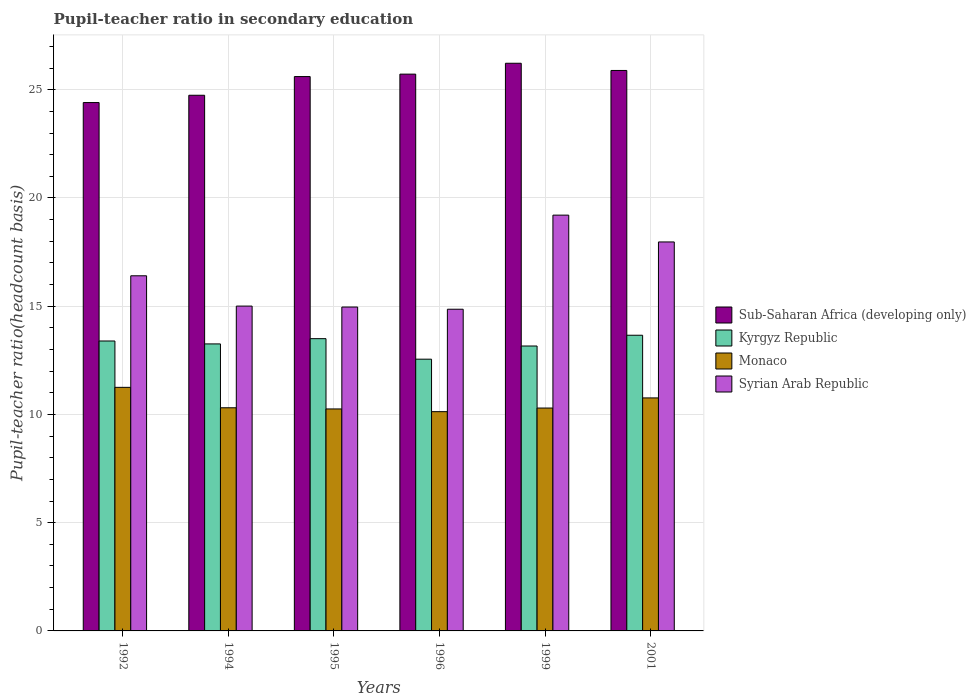How many groups of bars are there?
Keep it short and to the point. 6. How many bars are there on the 1st tick from the left?
Your response must be concise. 4. What is the label of the 6th group of bars from the left?
Ensure brevity in your answer.  2001. What is the pupil-teacher ratio in secondary education in Sub-Saharan Africa (developing only) in 1999?
Your answer should be very brief. 26.22. Across all years, what is the maximum pupil-teacher ratio in secondary education in Monaco?
Your answer should be very brief. 11.25. Across all years, what is the minimum pupil-teacher ratio in secondary education in Monaco?
Provide a short and direct response. 10.13. In which year was the pupil-teacher ratio in secondary education in Kyrgyz Republic maximum?
Ensure brevity in your answer.  2001. In which year was the pupil-teacher ratio in secondary education in Kyrgyz Republic minimum?
Keep it short and to the point. 1996. What is the total pupil-teacher ratio in secondary education in Sub-Saharan Africa (developing only) in the graph?
Make the answer very short. 152.6. What is the difference between the pupil-teacher ratio in secondary education in Sub-Saharan Africa (developing only) in 1992 and that in 1995?
Ensure brevity in your answer.  -1.2. What is the difference between the pupil-teacher ratio in secondary education in Monaco in 2001 and the pupil-teacher ratio in secondary education in Syrian Arab Republic in 1994?
Provide a succinct answer. -4.24. What is the average pupil-teacher ratio in secondary education in Syrian Arab Republic per year?
Provide a succinct answer. 16.4. In the year 1999, what is the difference between the pupil-teacher ratio in secondary education in Syrian Arab Republic and pupil-teacher ratio in secondary education in Kyrgyz Republic?
Provide a short and direct response. 6.05. In how many years, is the pupil-teacher ratio in secondary education in Kyrgyz Republic greater than 18?
Your answer should be very brief. 0. What is the ratio of the pupil-teacher ratio in secondary education in Kyrgyz Republic in 1996 to that in 2001?
Ensure brevity in your answer.  0.92. Is the pupil-teacher ratio in secondary education in Monaco in 1994 less than that in 2001?
Give a very brief answer. Yes. What is the difference between the highest and the second highest pupil-teacher ratio in secondary education in Monaco?
Provide a short and direct response. 0.49. What is the difference between the highest and the lowest pupil-teacher ratio in secondary education in Sub-Saharan Africa (developing only)?
Your answer should be very brief. 1.82. Is the sum of the pupil-teacher ratio in secondary education in Syrian Arab Republic in 1992 and 1996 greater than the maximum pupil-teacher ratio in secondary education in Monaco across all years?
Your response must be concise. Yes. Is it the case that in every year, the sum of the pupil-teacher ratio in secondary education in Syrian Arab Republic and pupil-teacher ratio in secondary education in Sub-Saharan Africa (developing only) is greater than the sum of pupil-teacher ratio in secondary education in Kyrgyz Republic and pupil-teacher ratio in secondary education in Monaco?
Provide a short and direct response. Yes. What does the 3rd bar from the left in 1996 represents?
Offer a very short reply. Monaco. What does the 4th bar from the right in 1995 represents?
Your response must be concise. Sub-Saharan Africa (developing only). How many years are there in the graph?
Give a very brief answer. 6. Are the values on the major ticks of Y-axis written in scientific E-notation?
Ensure brevity in your answer.  No. Does the graph contain grids?
Make the answer very short. Yes. Where does the legend appear in the graph?
Offer a very short reply. Center right. What is the title of the graph?
Your answer should be very brief. Pupil-teacher ratio in secondary education. Does "Greenland" appear as one of the legend labels in the graph?
Provide a short and direct response. No. What is the label or title of the Y-axis?
Offer a terse response. Pupil-teacher ratio(headcount basis). What is the Pupil-teacher ratio(headcount basis) in Sub-Saharan Africa (developing only) in 1992?
Offer a very short reply. 24.41. What is the Pupil-teacher ratio(headcount basis) in Kyrgyz Republic in 1992?
Provide a short and direct response. 13.39. What is the Pupil-teacher ratio(headcount basis) of Monaco in 1992?
Your response must be concise. 11.25. What is the Pupil-teacher ratio(headcount basis) of Syrian Arab Republic in 1992?
Provide a succinct answer. 16.41. What is the Pupil-teacher ratio(headcount basis) of Sub-Saharan Africa (developing only) in 1994?
Provide a short and direct response. 24.75. What is the Pupil-teacher ratio(headcount basis) of Kyrgyz Republic in 1994?
Offer a terse response. 13.26. What is the Pupil-teacher ratio(headcount basis) in Monaco in 1994?
Your answer should be very brief. 10.31. What is the Pupil-teacher ratio(headcount basis) in Syrian Arab Republic in 1994?
Offer a terse response. 15.01. What is the Pupil-teacher ratio(headcount basis) in Sub-Saharan Africa (developing only) in 1995?
Offer a terse response. 25.61. What is the Pupil-teacher ratio(headcount basis) in Kyrgyz Republic in 1995?
Offer a very short reply. 13.5. What is the Pupil-teacher ratio(headcount basis) in Monaco in 1995?
Ensure brevity in your answer.  10.25. What is the Pupil-teacher ratio(headcount basis) in Syrian Arab Republic in 1995?
Your answer should be very brief. 14.96. What is the Pupil-teacher ratio(headcount basis) of Sub-Saharan Africa (developing only) in 1996?
Keep it short and to the point. 25.72. What is the Pupil-teacher ratio(headcount basis) in Kyrgyz Republic in 1996?
Your answer should be compact. 12.55. What is the Pupil-teacher ratio(headcount basis) in Monaco in 1996?
Your response must be concise. 10.13. What is the Pupil-teacher ratio(headcount basis) of Syrian Arab Republic in 1996?
Keep it short and to the point. 14.86. What is the Pupil-teacher ratio(headcount basis) of Sub-Saharan Africa (developing only) in 1999?
Your answer should be compact. 26.22. What is the Pupil-teacher ratio(headcount basis) in Kyrgyz Republic in 1999?
Your response must be concise. 13.16. What is the Pupil-teacher ratio(headcount basis) in Monaco in 1999?
Keep it short and to the point. 10.3. What is the Pupil-teacher ratio(headcount basis) of Syrian Arab Republic in 1999?
Your answer should be very brief. 19.21. What is the Pupil-teacher ratio(headcount basis) in Sub-Saharan Africa (developing only) in 2001?
Provide a short and direct response. 25.89. What is the Pupil-teacher ratio(headcount basis) of Kyrgyz Republic in 2001?
Ensure brevity in your answer.  13.66. What is the Pupil-teacher ratio(headcount basis) of Monaco in 2001?
Keep it short and to the point. 10.76. What is the Pupil-teacher ratio(headcount basis) in Syrian Arab Republic in 2001?
Offer a very short reply. 17.97. Across all years, what is the maximum Pupil-teacher ratio(headcount basis) in Sub-Saharan Africa (developing only)?
Make the answer very short. 26.22. Across all years, what is the maximum Pupil-teacher ratio(headcount basis) in Kyrgyz Republic?
Your answer should be compact. 13.66. Across all years, what is the maximum Pupil-teacher ratio(headcount basis) in Monaco?
Your answer should be compact. 11.25. Across all years, what is the maximum Pupil-teacher ratio(headcount basis) of Syrian Arab Republic?
Make the answer very short. 19.21. Across all years, what is the minimum Pupil-teacher ratio(headcount basis) of Sub-Saharan Africa (developing only)?
Provide a succinct answer. 24.41. Across all years, what is the minimum Pupil-teacher ratio(headcount basis) of Kyrgyz Republic?
Ensure brevity in your answer.  12.55. Across all years, what is the minimum Pupil-teacher ratio(headcount basis) of Monaco?
Your answer should be compact. 10.13. Across all years, what is the minimum Pupil-teacher ratio(headcount basis) of Syrian Arab Republic?
Provide a short and direct response. 14.86. What is the total Pupil-teacher ratio(headcount basis) of Sub-Saharan Africa (developing only) in the graph?
Provide a succinct answer. 152.6. What is the total Pupil-teacher ratio(headcount basis) in Kyrgyz Republic in the graph?
Provide a short and direct response. 79.53. What is the total Pupil-teacher ratio(headcount basis) in Monaco in the graph?
Keep it short and to the point. 63.01. What is the total Pupil-teacher ratio(headcount basis) of Syrian Arab Republic in the graph?
Make the answer very short. 98.41. What is the difference between the Pupil-teacher ratio(headcount basis) of Sub-Saharan Africa (developing only) in 1992 and that in 1994?
Provide a succinct answer. -0.34. What is the difference between the Pupil-teacher ratio(headcount basis) of Kyrgyz Republic in 1992 and that in 1994?
Offer a very short reply. 0.13. What is the difference between the Pupil-teacher ratio(headcount basis) of Monaco in 1992 and that in 1994?
Provide a short and direct response. 0.94. What is the difference between the Pupil-teacher ratio(headcount basis) in Syrian Arab Republic in 1992 and that in 1994?
Your response must be concise. 1.4. What is the difference between the Pupil-teacher ratio(headcount basis) of Sub-Saharan Africa (developing only) in 1992 and that in 1995?
Ensure brevity in your answer.  -1.2. What is the difference between the Pupil-teacher ratio(headcount basis) in Kyrgyz Republic in 1992 and that in 1995?
Offer a terse response. -0.11. What is the difference between the Pupil-teacher ratio(headcount basis) of Syrian Arab Republic in 1992 and that in 1995?
Provide a succinct answer. 1.44. What is the difference between the Pupil-teacher ratio(headcount basis) of Sub-Saharan Africa (developing only) in 1992 and that in 1996?
Your response must be concise. -1.31. What is the difference between the Pupil-teacher ratio(headcount basis) of Kyrgyz Republic in 1992 and that in 1996?
Give a very brief answer. 0.84. What is the difference between the Pupil-teacher ratio(headcount basis) of Monaco in 1992 and that in 1996?
Give a very brief answer. 1.12. What is the difference between the Pupil-teacher ratio(headcount basis) in Syrian Arab Republic in 1992 and that in 1996?
Offer a very short reply. 1.54. What is the difference between the Pupil-teacher ratio(headcount basis) in Sub-Saharan Africa (developing only) in 1992 and that in 1999?
Your response must be concise. -1.82. What is the difference between the Pupil-teacher ratio(headcount basis) of Kyrgyz Republic in 1992 and that in 1999?
Your answer should be very brief. 0.23. What is the difference between the Pupil-teacher ratio(headcount basis) of Monaco in 1992 and that in 1999?
Give a very brief answer. 0.96. What is the difference between the Pupil-teacher ratio(headcount basis) in Syrian Arab Republic in 1992 and that in 1999?
Keep it short and to the point. -2.8. What is the difference between the Pupil-teacher ratio(headcount basis) of Sub-Saharan Africa (developing only) in 1992 and that in 2001?
Provide a succinct answer. -1.48. What is the difference between the Pupil-teacher ratio(headcount basis) of Kyrgyz Republic in 1992 and that in 2001?
Your response must be concise. -0.27. What is the difference between the Pupil-teacher ratio(headcount basis) of Monaco in 1992 and that in 2001?
Offer a very short reply. 0.49. What is the difference between the Pupil-teacher ratio(headcount basis) of Syrian Arab Republic in 1992 and that in 2001?
Ensure brevity in your answer.  -1.56. What is the difference between the Pupil-teacher ratio(headcount basis) in Sub-Saharan Africa (developing only) in 1994 and that in 1995?
Provide a short and direct response. -0.86. What is the difference between the Pupil-teacher ratio(headcount basis) of Kyrgyz Republic in 1994 and that in 1995?
Your response must be concise. -0.24. What is the difference between the Pupil-teacher ratio(headcount basis) in Monaco in 1994 and that in 1995?
Ensure brevity in your answer.  0.05. What is the difference between the Pupil-teacher ratio(headcount basis) of Syrian Arab Republic in 1994 and that in 1995?
Ensure brevity in your answer.  0.04. What is the difference between the Pupil-teacher ratio(headcount basis) in Sub-Saharan Africa (developing only) in 1994 and that in 1996?
Provide a succinct answer. -0.98. What is the difference between the Pupil-teacher ratio(headcount basis) in Kyrgyz Republic in 1994 and that in 1996?
Your response must be concise. 0.71. What is the difference between the Pupil-teacher ratio(headcount basis) of Monaco in 1994 and that in 1996?
Provide a succinct answer. 0.18. What is the difference between the Pupil-teacher ratio(headcount basis) of Syrian Arab Republic in 1994 and that in 1996?
Make the answer very short. 0.14. What is the difference between the Pupil-teacher ratio(headcount basis) in Sub-Saharan Africa (developing only) in 1994 and that in 1999?
Your answer should be very brief. -1.48. What is the difference between the Pupil-teacher ratio(headcount basis) in Kyrgyz Republic in 1994 and that in 1999?
Give a very brief answer. 0.1. What is the difference between the Pupil-teacher ratio(headcount basis) of Monaco in 1994 and that in 1999?
Provide a succinct answer. 0.01. What is the difference between the Pupil-teacher ratio(headcount basis) in Syrian Arab Republic in 1994 and that in 1999?
Ensure brevity in your answer.  -4.2. What is the difference between the Pupil-teacher ratio(headcount basis) of Sub-Saharan Africa (developing only) in 1994 and that in 2001?
Your answer should be compact. -1.15. What is the difference between the Pupil-teacher ratio(headcount basis) in Kyrgyz Republic in 1994 and that in 2001?
Your answer should be very brief. -0.4. What is the difference between the Pupil-teacher ratio(headcount basis) of Monaco in 1994 and that in 2001?
Your response must be concise. -0.46. What is the difference between the Pupil-teacher ratio(headcount basis) of Syrian Arab Republic in 1994 and that in 2001?
Make the answer very short. -2.96. What is the difference between the Pupil-teacher ratio(headcount basis) of Sub-Saharan Africa (developing only) in 1995 and that in 1996?
Your answer should be very brief. -0.11. What is the difference between the Pupil-teacher ratio(headcount basis) in Kyrgyz Republic in 1995 and that in 1996?
Make the answer very short. 0.95. What is the difference between the Pupil-teacher ratio(headcount basis) in Monaco in 1995 and that in 1996?
Your response must be concise. 0.13. What is the difference between the Pupil-teacher ratio(headcount basis) in Syrian Arab Republic in 1995 and that in 1996?
Make the answer very short. 0.1. What is the difference between the Pupil-teacher ratio(headcount basis) in Sub-Saharan Africa (developing only) in 1995 and that in 1999?
Keep it short and to the point. -0.61. What is the difference between the Pupil-teacher ratio(headcount basis) in Kyrgyz Republic in 1995 and that in 1999?
Make the answer very short. 0.34. What is the difference between the Pupil-teacher ratio(headcount basis) in Monaco in 1995 and that in 1999?
Keep it short and to the point. -0.04. What is the difference between the Pupil-teacher ratio(headcount basis) in Syrian Arab Republic in 1995 and that in 1999?
Provide a short and direct response. -4.25. What is the difference between the Pupil-teacher ratio(headcount basis) of Sub-Saharan Africa (developing only) in 1995 and that in 2001?
Your answer should be compact. -0.28. What is the difference between the Pupil-teacher ratio(headcount basis) of Kyrgyz Republic in 1995 and that in 2001?
Ensure brevity in your answer.  -0.16. What is the difference between the Pupil-teacher ratio(headcount basis) of Monaco in 1995 and that in 2001?
Offer a very short reply. -0.51. What is the difference between the Pupil-teacher ratio(headcount basis) in Syrian Arab Republic in 1995 and that in 2001?
Keep it short and to the point. -3.01. What is the difference between the Pupil-teacher ratio(headcount basis) in Sub-Saharan Africa (developing only) in 1996 and that in 1999?
Provide a short and direct response. -0.5. What is the difference between the Pupil-teacher ratio(headcount basis) in Kyrgyz Republic in 1996 and that in 1999?
Offer a terse response. -0.61. What is the difference between the Pupil-teacher ratio(headcount basis) in Monaco in 1996 and that in 1999?
Keep it short and to the point. -0.17. What is the difference between the Pupil-teacher ratio(headcount basis) in Syrian Arab Republic in 1996 and that in 1999?
Offer a very short reply. -4.35. What is the difference between the Pupil-teacher ratio(headcount basis) of Sub-Saharan Africa (developing only) in 1996 and that in 2001?
Ensure brevity in your answer.  -0.17. What is the difference between the Pupil-teacher ratio(headcount basis) of Kyrgyz Republic in 1996 and that in 2001?
Offer a very short reply. -1.11. What is the difference between the Pupil-teacher ratio(headcount basis) of Monaco in 1996 and that in 2001?
Provide a succinct answer. -0.64. What is the difference between the Pupil-teacher ratio(headcount basis) of Syrian Arab Republic in 1996 and that in 2001?
Give a very brief answer. -3.11. What is the difference between the Pupil-teacher ratio(headcount basis) in Sub-Saharan Africa (developing only) in 1999 and that in 2001?
Offer a terse response. 0.33. What is the difference between the Pupil-teacher ratio(headcount basis) in Kyrgyz Republic in 1999 and that in 2001?
Offer a very short reply. -0.5. What is the difference between the Pupil-teacher ratio(headcount basis) of Monaco in 1999 and that in 2001?
Offer a very short reply. -0.47. What is the difference between the Pupil-teacher ratio(headcount basis) of Syrian Arab Republic in 1999 and that in 2001?
Make the answer very short. 1.24. What is the difference between the Pupil-teacher ratio(headcount basis) in Sub-Saharan Africa (developing only) in 1992 and the Pupil-teacher ratio(headcount basis) in Kyrgyz Republic in 1994?
Your answer should be very brief. 11.15. What is the difference between the Pupil-teacher ratio(headcount basis) in Sub-Saharan Africa (developing only) in 1992 and the Pupil-teacher ratio(headcount basis) in Monaco in 1994?
Your answer should be compact. 14.1. What is the difference between the Pupil-teacher ratio(headcount basis) in Sub-Saharan Africa (developing only) in 1992 and the Pupil-teacher ratio(headcount basis) in Syrian Arab Republic in 1994?
Make the answer very short. 9.4. What is the difference between the Pupil-teacher ratio(headcount basis) of Kyrgyz Republic in 1992 and the Pupil-teacher ratio(headcount basis) of Monaco in 1994?
Offer a very short reply. 3.08. What is the difference between the Pupil-teacher ratio(headcount basis) of Kyrgyz Republic in 1992 and the Pupil-teacher ratio(headcount basis) of Syrian Arab Republic in 1994?
Your answer should be very brief. -1.61. What is the difference between the Pupil-teacher ratio(headcount basis) of Monaco in 1992 and the Pupil-teacher ratio(headcount basis) of Syrian Arab Republic in 1994?
Offer a very short reply. -3.75. What is the difference between the Pupil-teacher ratio(headcount basis) in Sub-Saharan Africa (developing only) in 1992 and the Pupil-teacher ratio(headcount basis) in Kyrgyz Republic in 1995?
Your answer should be very brief. 10.91. What is the difference between the Pupil-teacher ratio(headcount basis) of Sub-Saharan Africa (developing only) in 1992 and the Pupil-teacher ratio(headcount basis) of Monaco in 1995?
Offer a very short reply. 14.15. What is the difference between the Pupil-teacher ratio(headcount basis) of Sub-Saharan Africa (developing only) in 1992 and the Pupil-teacher ratio(headcount basis) of Syrian Arab Republic in 1995?
Your answer should be very brief. 9.45. What is the difference between the Pupil-teacher ratio(headcount basis) of Kyrgyz Republic in 1992 and the Pupil-teacher ratio(headcount basis) of Monaco in 1995?
Offer a terse response. 3.14. What is the difference between the Pupil-teacher ratio(headcount basis) in Kyrgyz Republic in 1992 and the Pupil-teacher ratio(headcount basis) in Syrian Arab Republic in 1995?
Your response must be concise. -1.57. What is the difference between the Pupil-teacher ratio(headcount basis) of Monaco in 1992 and the Pupil-teacher ratio(headcount basis) of Syrian Arab Republic in 1995?
Offer a very short reply. -3.71. What is the difference between the Pupil-teacher ratio(headcount basis) of Sub-Saharan Africa (developing only) in 1992 and the Pupil-teacher ratio(headcount basis) of Kyrgyz Republic in 1996?
Make the answer very short. 11.85. What is the difference between the Pupil-teacher ratio(headcount basis) of Sub-Saharan Africa (developing only) in 1992 and the Pupil-teacher ratio(headcount basis) of Monaco in 1996?
Make the answer very short. 14.28. What is the difference between the Pupil-teacher ratio(headcount basis) in Sub-Saharan Africa (developing only) in 1992 and the Pupil-teacher ratio(headcount basis) in Syrian Arab Republic in 1996?
Make the answer very short. 9.55. What is the difference between the Pupil-teacher ratio(headcount basis) of Kyrgyz Republic in 1992 and the Pupil-teacher ratio(headcount basis) of Monaco in 1996?
Offer a very short reply. 3.26. What is the difference between the Pupil-teacher ratio(headcount basis) of Kyrgyz Republic in 1992 and the Pupil-teacher ratio(headcount basis) of Syrian Arab Republic in 1996?
Your response must be concise. -1.47. What is the difference between the Pupil-teacher ratio(headcount basis) of Monaco in 1992 and the Pupil-teacher ratio(headcount basis) of Syrian Arab Republic in 1996?
Provide a succinct answer. -3.61. What is the difference between the Pupil-teacher ratio(headcount basis) in Sub-Saharan Africa (developing only) in 1992 and the Pupil-teacher ratio(headcount basis) in Kyrgyz Republic in 1999?
Give a very brief answer. 11.25. What is the difference between the Pupil-teacher ratio(headcount basis) in Sub-Saharan Africa (developing only) in 1992 and the Pupil-teacher ratio(headcount basis) in Monaco in 1999?
Provide a succinct answer. 14.11. What is the difference between the Pupil-teacher ratio(headcount basis) of Sub-Saharan Africa (developing only) in 1992 and the Pupil-teacher ratio(headcount basis) of Syrian Arab Republic in 1999?
Ensure brevity in your answer.  5.2. What is the difference between the Pupil-teacher ratio(headcount basis) of Kyrgyz Republic in 1992 and the Pupil-teacher ratio(headcount basis) of Monaco in 1999?
Make the answer very short. 3.1. What is the difference between the Pupil-teacher ratio(headcount basis) of Kyrgyz Republic in 1992 and the Pupil-teacher ratio(headcount basis) of Syrian Arab Republic in 1999?
Offer a terse response. -5.81. What is the difference between the Pupil-teacher ratio(headcount basis) of Monaco in 1992 and the Pupil-teacher ratio(headcount basis) of Syrian Arab Republic in 1999?
Offer a terse response. -7.96. What is the difference between the Pupil-teacher ratio(headcount basis) in Sub-Saharan Africa (developing only) in 1992 and the Pupil-teacher ratio(headcount basis) in Kyrgyz Republic in 2001?
Make the answer very short. 10.75. What is the difference between the Pupil-teacher ratio(headcount basis) in Sub-Saharan Africa (developing only) in 1992 and the Pupil-teacher ratio(headcount basis) in Monaco in 2001?
Offer a very short reply. 13.64. What is the difference between the Pupil-teacher ratio(headcount basis) in Sub-Saharan Africa (developing only) in 1992 and the Pupil-teacher ratio(headcount basis) in Syrian Arab Republic in 2001?
Your answer should be compact. 6.44. What is the difference between the Pupil-teacher ratio(headcount basis) in Kyrgyz Republic in 1992 and the Pupil-teacher ratio(headcount basis) in Monaco in 2001?
Make the answer very short. 2.63. What is the difference between the Pupil-teacher ratio(headcount basis) in Kyrgyz Republic in 1992 and the Pupil-teacher ratio(headcount basis) in Syrian Arab Republic in 2001?
Provide a succinct answer. -4.58. What is the difference between the Pupil-teacher ratio(headcount basis) of Monaco in 1992 and the Pupil-teacher ratio(headcount basis) of Syrian Arab Republic in 2001?
Ensure brevity in your answer.  -6.72. What is the difference between the Pupil-teacher ratio(headcount basis) of Sub-Saharan Africa (developing only) in 1994 and the Pupil-teacher ratio(headcount basis) of Kyrgyz Republic in 1995?
Your response must be concise. 11.25. What is the difference between the Pupil-teacher ratio(headcount basis) of Sub-Saharan Africa (developing only) in 1994 and the Pupil-teacher ratio(headcount basis) of Monaco in 1995?
Your response must be concise. 14.49. What is the difference between the Pupil-teacher ratio(headcount basis) of Sub-Saharan Africa (developing only) in 1994 and the Pupil-teacher ratio(headcount basis) of Syrian Arab Republic in 1995?
Provide a succinct answer. 9.78. What is the difference between the Pupil-teacher ratio(headcount basis) of Kyrgyz Republic in 1994 and the Pupil-teacher ratio(headcount basis) of Monaco in 1995?
Ensure brevity in your answer.  3. What is the difference between the Pupil-teacher ratio(headcount basis) in Kyrgyz Republic in 1994 and the Pupil-teacher ratio(headcount basis) in Syrian Arab Republic in 1995?
Offer a very short reply. -1.7. What is the difference between the Pupil-teacher ratio(headcount basis) of Monaco in 1994 and the Pupil-teacher ratio(headcount basis) of Syrian Arab Republic in 1995?
Make the answer very short. -4.65. What is the difference between the Pupil-teacher ratio(headcount basis) in Sub-Saharan Africa (developing only) in 1994 and the Pupil-teacher ratio(headcount basis) in Kyrgyz Republic in 1996?
Your answer should be compact. 12.19. What is the difference between the Pupil-teacher ratio(headcount basis) of Sub-Saharan Africa (developing only) in 1994 and the Pupil-teacher ratio(headcount basis) of Monaco in 1996?
Give a very brief answer. 14.62. What is the difference between the Pupil-teacher ratio(headcount basis) of Sub-Saharan Africa (developing only) in 1994 and the Pupil-teacher ratio(headcount basis) of Syrian Arab Republic in 1996?
Offer a terse response. 9.88. What is the difference between the Pupil-teacher ratio(headcount basis) in Kyrgyz Republic in 1994 and the Pupil-teacher ratio(headcount basis) in Monaco in 1996?
Your answer should be compact. 3.13. What is the difference between the Pupil-teacher ratio(headcount basis) in Kyrgyz Republic in 1994 and the Pupil-teacher ratio(headcount basis) in Syrian Arab Republic in 1996?
Keep it short and to the point. -1.6. What is the difference between the Pupil-teacher ratio(headcount basis) in Monaco in 1994 and the Pupil-teacher ratio(headcount basis) in Syrian Arab Republic in 1996?
Provide a short and direct response. -4.55. What is the difference between the Pupil-teacher ratio(headcount basis) of Sub-Saharan Africa (developing only) in 1994 and the Pupil-teacher ratio(headcount basis) of Kyrgyz Republic in 1999?
Provide a short and direct response. 11.58. What is the difference between the Pupil-teacher ratio(headcount basis) of Sub-Saharan Africa (developing only) in 1994 and the Pupil-teacher ratio(headcount basis) of Monaco in 1999?
Provide a succinct answer. 14.45. What is the difference between the Pupil-teacher ratio(headcount basis) in Sub-Saharan Africa (developing only) in 1994 and the Pupil-teacher ratio(headcount basis) in Syrian Arab Republic in 1999?
Give a very brief answer. 5.54. What is the difference between the Pupil-teacher ratio(headcount basis) of Kyrgyz Republic in 1994 and the Pupil-teacher ratio(headcount basis) of Monaco in 1999?
Make the answer very short. 2.96. What is the difference between the Pupil-teacher ratio(headcount basis) in Kyrgyz Republic in 1994 and the Pupil-teacher ratio(headcount basis) in Syrian Arab Republic in 1999?
Your answer should be compact. -5.95. What is the difference between the Pupil-teacher ratio(headcount basis) in Monaco in 1994 and the Pupil-teacher ratio(headcount basis) in Syrian Arab Republic in 1999?
Your answer should be very brief. -8.9. What is the difference between the Pupil-teacher ratio(headcount basis) of Sub-Saharan Africa (developing only) in 1994 and the Pupil-teacher ratio(headcount basis) of Kyrgyz Republic in 2001?
Give a very brief answer. 11.09. What is the difference between the Pupil-teacher ratio(headcount basis) of Sub-Saharan Africa (developing only) in 1994 and the Pupil-teacher ratio(headcount basis) of Monaco in 2001?
Make the answer very short. 13.98. What is the difference between the Pupil-teacher ratio(headcount basis) of Sub-Saharan Africa (developing only) in 1994 and the Pupil-teacher ratio(headcount basis) of Syrian Arab Republic in 2001?
Provide a succinct answer. 6.78. What is the difference between the Pupil-teacher ratio(headcount basis) of Kyrgyz Republic in 1994 and the Pupil-teacher ratio(headcount basis) of Monaco in 2001?
Ensure brevity in your answer.  2.49. What is the difference between the Pupil-teacher ratio(headcount basis) in Kyrgyz Republic in 1994 and the Pupil-teacher ratio(headcount basis) in Syrian Arab Republic in 2001?
Your answer should be compact. -4.71. What is the difference between the Pupil-teacher ratio(headcount basis) of Monaco in 1994 and the Pupil-teacher ratio(headcount basis) of Syrian Arab Republic in 2001?
Your answer should be compact. -7.66. What is the difference between the Pupil-teacher ratio(headcount basis) in Sub-Saharan Africa (developing only) in 1995 and the Pupil-teacher ratio(headcount basis) in Kyrgyz Republic in 1996?
Your response must be concise. 13.06. What is the difference between the Pupil-teacher ratio(headcount basis) of Sub-Saharan Africa (developing only) in 1995 and the Pupil-teacher ratio(headcount basis) of Monaco in 1996?
Provide a short and direct response. 15.48. What is the difference between the Pupil-teacher ratio(headcount basis) of Sub-Saharan Africa (developing only) in 1995 and the Pupil-teacher ratio(headcount basis) of Syrian Arab Republic in 1996?
Your response must be concise. 10.75. What is the difference between the Pupil-teacher ratio(headcount basis) in Kyrgyz Republic in 1995 and the Pupil-teacher ratio(headcount basis) in Monaco in 1996?
Make the answer very short. 3.37. What is the difference between the Pupil-teacher ratio(headcount basis) in Kyrgyz Republic in 1995 and the Pupil-teacher ratio(headcount basis) in Syrian Arab Republic in 1996?
Offer a terse response. -1.36. What is the difference between the Pupil-teacher ratio(headcount basis) of Monaco in 1995 and the Pupil-teacher ratio(headcount basis) of Syrian Arab Republic in 1996?
Make the answer very short. -4.61. What is the difference between the Pupil-teacher ratio(headcount basis) of Sub-Saharan Africa (developing only) in 1995 and the Pupil-teacher ratio(headcount basis) of Kyrgyz Republic in 1999?
Your answer should be compact. 12.45. What is the difference between the Pupil-teacher ratio(headcount basis) in Sub-Saharan Africa (developing only) in 1995 and the Pupil-teacher ratio(headcount basis) in Monaco in 1999?
Provide a short and direct response. 15.31. What is the difference between the Pupil-teacher ratio(headcount basis) of Sub-Saharan Africa (developing only) in 1995 and the Pupil-teacher ratio(headcount basis) of Syrian Arab Republic in 1999?
Give a very brief answer. 6.4. What is the difference between the Pupil-teacher ratio(headcount basis) of Kyrgyz Republic in 1995 and the Pupil-teacher ratio(headcount basis) of Monaco in 1999?
Provide a short and direct response. 3.2. What is the difference between the Pupil-teacher ratio(headcount basis) in Kyrgyz Republic in 1995 and the Pupil-teacher ratio(headcount basis) in Syrian Arab Republic in 1999?
Ensure brevity in your answer.  -5.71. What is the difference between the Pupil-teacher ratio(headcount basis) in Monaco in 1995 and the Pupil-teacher ratio(headcount basis) in Syrian Arab Republic in 1999?
Offer a very short reply. -8.95. What is the difference between the Pupil-teacher ratio(headcount basis) of Sub-Saharan Africa (developing only) in 1995 and the Pupil-teacher ratio(headcount basis) of Kyrgyz Republic in 2001?
Provide a succinct answer. 11.95. What is the difference between the Pupil-teacher ratio(headcount basis) in Sub-Saharan Africa (developing only) in 1995 and the Pupil-teacher ratio(headcount basis) in Monaco in 2001?
Offer a terse response. 14.85. What is the difference between the Pupil-teacher ratio(headcount basis) in Sub-Saharan Africa (developing only) in 1995 and the Pupil-teacher ratio(headcount basis) in Syrian Arab Republic in 2001?
Your response must be concise. 7.64. What is the difference between the Pupil-teacher ratio(headcount basis) in Kyrgyz Republic in 1995 and the Pupil-teacher ratio(headcount basis) in Monaco in 2001?
Make the answer very short. 2.74. What is the difference between the Pupil-teacher ratio(headcount basis) in Kyrgyz Republic in 1995 and the Pupil-teacher ratio(headcount basis) in Syrian Arab Republic in 2001?
Keep it short and to the point. -4.47. What is the difference between the Pupil-teacher ratio(headcount basis) in Monaco in 1995 and the Pupil-teacher ratio(headcount basis) in Syrian Arab Republic in 2001?
Your answer should be very brief. -7.72. What is the difference between the Pupil-teacher ratio(headcount basis) in Sub-Saharan Africa (developing only) in 1996 and the Pupil-teacher ratio(headcount basis) in Kyrgyz Republic in 1999?
Make the answer very short. 12.56. What is the difference between the Pupil-teacher ratio(headcount basis) of Sub-Saharan Africa (developing only) in 1996 and the Pupil-teacher ratio(headcount basis) of Monaco in 1999?
Your answer should be very brief. 15.43. What is the difference between the Pupil-teacher ratio(headcount basis) of Sub-Saharan Africa (developing only) in 1996 and the Pupil-teacher ratio(headcount basis) of Syrian Arab Republic in 1999?
Offer a terse response. 6.51. What is the difference between the Pupil-teacher ratio(headcount basis) in Kyrgyz Republic in 1996 and the Pupil-teacher ratio(headcount basis) in Monaco in 1999?
Your response must be concise. 2.26. What is the difference between the Pupil-teacher ratio(headcount basis) in Kyrgyz Republic in 1996 and the Pupil-teacher ratio(headcount basis) in Syrian Arab Republic in 1999?
Keep it short and to the point. -6.65. What is the difference between the Pupil-teacher ratio(headcount basis) in Monaco in 1996 and the Pupil-teacher ratio(headcount basis) in Syrian Arab Republic in 1999?
Make the answer very short. -9.08. What is the difference between the Pupil-teacher ratio(headcount basis) of Sub-Saharan Africa (developing only) in 1996 and the Pupil-teacher ratio(headcount basis) of Kyrgyz Republic in 2001?
Keep it short and to the point. 12.06. What is the difference between the Pupil-teacher ratio(headcount basis) in Sub-Saharan Africa (developing only) in 1996 and the Pupil-teacher ratio(headcount basis) in Monaco in 2001?
Ensure brevity in your answer.  14.96. What is the difference between the Pupil-teacher ratio(headcount basis) in Sub-Saharan Africa (developing only) in 1996 and the Pupil-teacher ratio(headcount basis) in Syrian Arab Republic in 2001?
Ensure brevity in your answer.  7.75. What is the difference between the Pupil-teacher ratio(headcount basis) of Kyrgyz Republic in 1996 and the Pupil-teacher ratio(headcount basis) of Monaco in 2001?
Provide a short and direct response. 1.79. What is the difference between the Pupil-teacher ratio(headcount basis) in Kyrgyz Republic in 1996 and the Pupil-teacher ratio(headcount basis) in Syrian Arab Republic in 2001?
Offer a terse response. -5.42. What is the difference between the Pupil-teacher ratio(headcount basis) of Monaco in 1996 and the Pupil-teacher ratio(headcount basis) of Syrian Arab Republic in 2001?
Your answer should be compact. -7.84. What is the difference between the Pupil-teacher ratio(headcount basis) in Sub-Saharan Africa (developing only) in 1999 and the Pupil-teacher ratio(headcount basis) in Kyrgyz Republic in 2001?
Your answer should be compact. 12.57. What is the difference between the Pupil-teacher ratio(headcount basis) in Sub-Saharan Africa (developing only) in 1999 and the Pupil-teacher ratio(headcount basis) in Monaco in 2001?
Provide a succinct answer. 15.46. What is the difference between the Pupil-teacher ratio(headcount basis) of Sub-Saharan Africa (developing only) in 1999 and the Pupil-teacher ratio(headcount basis) of Syrian Arab Republic in 2001?
Provide a succinct answer. 8.25. What is the difference between the Pupil-teacher ratio(headcount basis) of Kyrgyz Republic in 1999 and the Pupil-teacher ratio(headcount basis) of Monaco in 2001?
Make the answer very short. 2.4. What is the difference between the Pupil-teacher ratio(headcount basis) in Kyrgyz Republic in 1999 and the Pupil-teacher ratio(headcount basis) in Syrian Arab Republic in 2001?
Your answer should be compact. -4.81. What is the difference between the Pupil-teacher ratio(headcount basis) in Monaco in 1999 and the Pupil-teacher ratio(headcount basis) in Syrian Arab Republic in 2001?
Provide a succinct answer. -7.67. What is the average Pupil-teacher ratio(headcount basis) of Sub-Saharan Africa (developing only) per year?
Keep it short and to the point. 25.43. What is the average Pupil-teacher ratio(headcount basis) of Kyrgyz Republic per year?
Make the answer very short. 13.25. What is the average Pupil-teacher ratio(headcount basis) in Monaco per year?
Give a very brief answer. 10.5. What is the average Pupil-teacher ratio(headcount basis) in Syrian Arab Republic per year?
Make the answer very short. 16.4. In the year 1992, what is the difference between the Pupil-teacher ratio(headcount basis) of Sub-Saharan Africa (developing only) and Pupil-teacher ratio(headcount basis) of Kyrgyz Republic?
Keep it short and to the point. 11.01. In the year 1992, what is the difference between the Pupil-teacher ratio(headcount basis) in Sub-Saharan Africa (developing only) and Pupil-teacher ratio(headcount basis) in Monaco?
Provide a succinct answer. 13.16. In the year 1992, what is the difference between the Pupil-teacher ratio(headcount basis) of Sub-Saharan Africa (developing only) and Pupil-teacher ratio(headcount basis) of Syrian Arab Republic?
Offer a terse response. 8. In the year 1992, what is the difference between the Pupil-teacher ratio(headcount basis) of Kyrgyz Republic and Pupil-teacher ratio(headcount basis) of Monaco?
Offer a terse response. 2.14. In the year 1992, what is the difference between the Pupil-teacher ratio(headcount basis) in Kyrgyz Republic and Pupil-teacher ratio(headcount basis) in Syrian Arab Republic?
Provide a short and direct response. -3.01. In the year 1992, what is the difference between the Pupil-teacher ratio(headcount basis) in Monaco and Pupil-teacher ratio(headcount basis) in Syrian Arab Republic?
Your answer should be compact. -5.15. In the year 1994, what is the difference between the Pupil-teacher ratio(headcount basis) in Sub-Saharan Africa (developing only) and Pupil-teacher ratio(headcount basis) in Kyrgyz Republic?
Give a very brief answer. 11.49. In the year 1994, what is the difference between the Pupil-teacher ratio(headcount basis) in Sub-Saharan Africa (developing only) and Pupil-teacher ratio(headcount basis) in Monaco?
Your response must be concise. 14.44. In the year 1994, what is the difference between the Pupil-teacher ratio(headcount basis) of Sub-Saharan Africa (developing only) and Pupil-teacher ratio(headcount basis) of Syrian Arab Republic?
Your answer should be very brief. 9.74. In the year 1994, what is the difference between the Pupil-teacher ratio(headcount basis) in Kyrgyz Republic and Pupil-teacher ratio(headcount basis) in Monaco?
Offer a terse response. 2.95. In the year 1994, what is the difference between the Pupil-teacher ratio(headcount basis) of Kyrgyz Republic and Pupil-teacher ratio(headcount basis) of Syrian Arab Republic?
Your answer should be very brief. -1.75. In the year 1994, what is the difference between the Pupil-teacher ratio(headcount basis) in Monaco and Pupil-teacher ratio(headcount basis) in Syrian Arab Republic?
Make the answer very short. -4.7. In the year 1995, what is the difference between the Pupil-teacher ratio(headcount basis) of Sub-Saharan Africa (developing only) and Pupil-teacher ratio(headcount basis) of Kyrgyz Republic?
Make the answer very short. 12.11. In the year 1995, what is the difference between the Pupil-teacher ratio(headcount basis) of Sub-Saharan Africa (developing only) and Pupil-teacher ratio(headcount basis) of Monaco?
Your answer should be compact. 15.36. In the year 1995, what is the difference between the Pupil-teacher ratio(headcount basis) in Sub-Saharan Africa (developing only) and Pupil-teacher ratio(headcount basis) in Syrian Arab Republic?
Provide a short and direct response. 10.65. In the year 1995, what is the difference between the Pupil-teacher ratio(headcount basis) of Kyrgyz Republic and Pupil-teacher ratio(headcount basis) of Monaco?
Give a very brief answer. 3.25. In the year 1995, what is the difference between the Pupil-teacher ratio(headcount basis) in Kyrgyz Republic and Pupil-teacher ratio(headcount basis) in Syrian Arab Republic?
Provide a succinct answer. -1.46. In the year 1995, what is the difference between the Pupil-teacher ratio(headcount basis) in Monaco and Pupil-teacher ratio(headcount basis) in Syrian Arab Republic?
Provide a succinct answer. -4.71. In the year 1996, what is the difference between the Pupil-teacher ratio(headcount basis) of Sub-Saharan Africa (developing only) and Pupil-teacher ratio(headcount basis) of Kyrgyz Republic?
Provide a succinct answer. 13.17. In the year 1996, what is the difference between the Pupil-teacher ratio(headcount basis) of Sub-Saharan Africa (developing only) and Pupil-teacher ratio(headcount basis) of Monaco?
Ensure brevity in your answer.  15.59. In the year 1996, what is the difference between the Pupil-teacher ratio(headcount basis) of Sub-Saharan Africa (developing only) and Pupil-teacher ratio(headcount basis) of Syrian Arab Republic?
Offer a very short reply. 10.86. In the year 1996, what is the difference between the Pupil-teacher ratio(headcount basis) in Kyrgyz Republic and Pupil-teacher ratio(headcount basis) in Monaco?
Your answer should be very brief. 2.42. In the year 1996, what is the difference between the Pupil-teacher ratio(headcount basis) in Kyrgyz Republic and Pupil-teacher ratio(headcount basis) in Syrian Arab Republic?
Offer a very short reply. -2.31. In the year 1996, what is the difference between the Pupil-teacher ratio(headcount basis) in Monaco and Pupil-teacher ratio(headcount basis) in Syrian Arab Republic?
Keep it short and to the point. -4.73. In the year 1999, what is the difference between the Pupil-teacher ratio(headcount basis) of Sub-Saharan Africa (developing only) and Pupil-teacher ratio(headcount basis) of Kyrgyz Republic?
Offer a very short reply. 13.06. In the year 1999, what is the difference between the Pupil-teacher ratio(headcount basis) in Sub-Saharan Africa (developing only) and Pupil-teacher ratio(headcount basis) in Monaco?
Provide a short and direct response. 15.93. In the year 1999, what is the difference between the Pupil-teacher ratio(headcount basis) in Sub-Saharan Africa (developing only) and Pupil-teacher ratio(headcount basis) in Syrian Arab Republic?
Make the answer very short. 7.02. In the year 1999, what is the difference between the Pupil-teacher ratio(headcount basis) of Kyrgyz Republic and Pupil-teacher ratio(headcount basis) of Monaco?
Your answer should be very brief. 2.87. In the year 1999, what is the difference between the Pupil-teacher ratio(headcount basis) in Kyrgyz Republic and Pupil-teacher ratio(headcount basis) in Syrian Arab Republic?
Make the answer very short. -6.05. In the year 1999, what is the difference between the Pupil-teacher ratio(headcount basis) in Monaco and Pupil-teacher ratio(headcount basis) in Syrian Arab Republic?
Make the answer very short. -8.91. In the year 2001, what is the difference between the Pupil-teacher ratio(headcount basis) in Sub-Saharan Africa (developing only) and Pupil-teacher ratio(headcount basis) in Kyrgyz Republic?
Your answer should be very brief. 12.23. In the year 2001, what is the difference between the Pupil-teacher ratio(headcount basis) of Sub-Saharan Africa (developing only) and Pupil-teacher ratio(headcount basis) of Monaco?
Your response must be concise. 15.13. In the year 2001, what is the difference between the Pupil-teacher ratio(headcount basis) in Sub-Saharan Africa (developing only) and Pupil-teacher ratio(headcount basis) in Syrian Arab Republic?
Offer a terse response. 7.92. In the year 2001, what is the difference between the Pupil-teacher ratio(headcount basis) of Kyrgyz Republic and Pupil-teacher ratio(headcount basis) of Monaco?
Keep it short and to the point. 2.89. In the year 2001, what is the difference between the Pupil-teacher ratio(headcount basis) in Kyrgyz Republic and Pupil-teacher ratio(headcount basis) in Syrian Arab Republic?
Provide a short and direct response. -4.31. In the year 2001, what is the difference between the Pupil-teacher ratio(headcount basis) of Monaco and Pupil-teacher ratio(headcount basis) of Syrian Arab Republic?
Keep it short and to the point. -7.21. What is the ratio of the Pupil-teacher ratio(headcount basis) in Sub-Saharan Africa (developing only) in 1992 to that in 1994?
Your answer should be very brief. 0.99. What is the ratio of the Pupil-teacher ratio(headcount basis) in Kyrgyz Republic in 1992 to that in 1994?
Make the answer very short. 1.01. What is the ratio of the Pupil-teacher ratio(headcount basis) in Monaco in 1992 to that in 1994?
Ensure brevity in your answer.  1.09. What is the ratio of the Pupil-teacher ratio(headcount basis) of Syrian Arab Republic in 1992 to that in 1994?
Provide a succinct answer. 1.09. What is the ratio of the Pupil-teacher ratio(headcount basis) of Sub-Saharan Africa (developing only) in 1992 to that in 1995?
Keep it short and to the point. 0.95. What is the ratio of the Pupil-teacher ratio(headcount basis) of Kyrgyz Republic in 1992 to that in 1995?
Provide a short and direct response. 0.99. What is the ratio of the Pupil-teacher ratio(headcount basis) in Monaco in 1992 to that in 1995?
Offer a very short reply. 1.1. What is the ratio of the Pupil-teacher ratio(headcount basis) of Syrian Arab Republic in 1992 to that in 1995?
Make the answer very short. 1.1. What is the ratio of the Pupil-teacher ratio(headcount basis) in Sub-Saharan Africa (developing only) in 1992 to that in 1996?
Ensure brevity in your answer.  0.95. What is the ratio of the Pupil-teacher ratio(headcount basis) of Kyrgyz Republic in 1992 to that in 1996?
Ensure brevity in your answer.  1.07. What is the ratio of the Pupil-teacher ratio(headcount basis) of Monaco in 1992 to that in 1996?
Make the answer very short. 1.11. What is the ratio of the Pupil-teacher ratio(headcount basis) in Syrian Arab Republic in 1992 to that in 1996?
Provide a short and direct response. 1.1. What is the ratio of the Pupil-teacher ratio(headcount basis) in Sub-Saharan Africa (developing only) in 1992 to that in 1999?
Offer a very short reply. 0.93. What is the ratio of the Pupil-teacher ratio(headcount basis) in Kyrgyz Republic in 1992 to that in 1999?
Offer a very short reply. 1.02. What is the ratio of the Pupil-teacher ratio(headcount basis) of Monaco in 1992 to that in 1999?
Your answer should be very brief. 1.09. What is the ratio of the Pupil-teacher ratio(headcount basis) in Syrian Arab Republic in 1992 to that in 1999?
Keep it short and to the point. 0.85. What is the ratio of the Pupil-teacher ratio(headcount basis) in Sub-Saharan Africa (developing only) in 1992 to that in 2001?
Provide a short and direct response. 0.94. What is the ratio of the Pupil-teacher ratio(headcount basis) of Kyrgyz Republic in 1992 to that in 2001?
Your response must be concise. 0.98. What is the ratio of the Pupil-teacher ratio(headcount basis) in Monaco in 1992 to that in 2001?
Your response must be concise. 1.05. What is the ratio of the Pupil-teacher ratio(headcount basis) of Syrian Arab Republic in 1992 to that in 2001?
Offer a terse response. 0.91. What is the ratio of the Pupil-teacher ratio(headcount basis) in Sub-Saharan Africa (developing only) in 1994 to that in 1995?
Provide a short and direct response. 0.97. What is the ratio of the Pupil-teacher ratio(headcount basis) of Kyrgyz Republic in 1994 to that in 1995?
Keep it short and to the point. 0.98. What is the ratio of the Pupil-teacher ratio(headcount basis) in Monaco in 1994 to that in 1995?
Ensure brevity in your answer.  1.01. What is the ratio of the Pupil-teacher ratio(headcount basis) in Syrian Arab Republic in 1994 to that in 1995?
Provide a short and direct response. 1. What is the ratio of the Pupil-teacher ratio(headcount basis) in Sub-Saharan Africa (developing only) in 1994 to that in 1996?
Make the answer very short. 0.96. What is the ratio of the Pupil-teacher ratio(headcount basis) of Kyrgyz Republic in 1994 to that in 1996?
Offer a very short reply. 1.06. What is the ratio of the Pupil-teacher ratio(headcount basis) in Monaco in 1994 to that in 1996?
Make the answer very short. 1.02. What is the ratio of the Pupil-teacher ratio(headcount basis) of Syrian Arab Republic in 1994 to that in 1996?
Your answer should be compact. 1.01. What is the ratio of the Pupil-teacher ratio(headcount basis) of Sub-Saharan Africa (developing only) in 1994 to that in 1999?
Your answer should be very brief. 0.94. What is the ratio of the Pupil-teacher ratio(headcount basis) of Kyrgyz Republic in 1994 to that in 1999?
Your answer should be compact. 1.01. What is the ratio of the Pupil-teacher ratio(headcount basis) of Monaco in 1994 to that in 1999?
Offer a terse response. 1. What is the ratio of the Pupil-teacher ratio(headcount basis) of Syrian Arab Republic in 1994 to that in 1999?
Offer a terse response. 0.78. What is the ratio of the Pupil-teacher ratio(headcount basis) of Sub-Saharan Africa (developing only) in 1994 to that in 2001?
Your answer should be compact. 0.96. What is the ratio of the Pupil-teacher ratio(headcount basis) of Kyrgyz Republic in 1994 to that in 2001?
Your answer should be compact. 0.97. What is the ratio of the Pupil-teacher ratio(headcount basis) of Monaco in 1994 to that in 2001?
Give a very brief answer. 0.96. What is the ratio of the Pupil-teacher ratio(headcount basis) of Syrian Arab Republic in 1994 to that in 2001?
Ensure brevity in your answer.  0.84. What is the ratio of the Pupil-teacher ratio(headcount basis) of Kyrgyz Republic in 1995 to that in 1996?
Keep it short and to the point. 1.08. What is the ratio of the Pupil-teacher ratio(headcount basis) in Monaco in 1995 to that in 1996?
Offer a terse response. 1.01. What is the ratio of the Pupil-teacher ratio(headcount basis) in Syrian Arab Republic in 1995 to that in 1996?
Keep it short and to the point. 1.01. What is the ratio of the Pupil-teacher ratio(headcount basis) of Sub-Saharan Africa (developing only) in 1995 to that in 1999?
Your answer should be compact. 0.98. What is the ratio of the Pupil-teacher ratio(headcount basis) of Kyrgyz Republic in 1995 to that in 1999?
Give a very brief answer. 1.03. What is the ratio of the Pupil-teacher ratio(headcount basis) of Syrian Arab Republic in 1995 to that in 1999?
Provide a succinct answer. 0.78. What is the ratio of the Pupil-teacher ratio(headcount basis) in Kyrgyz Republic in 1995 to that in 2001?
Provide a short and direct response. 0.99. What is the ratio of the Pupil-teacher ratio(headcount basis) of Monaco in 1995 to that in 2001?
Your answer should be very brief. 0.95. What is the ratio of the Pupil-teacher ratio(headcount basis) in Syrian Arab Republic in 1995 to that in 2001?
Offer a very short reply. 0.83. What is the ratio of the Pupil-teacher ratio(headcount basis) of Sub-Saharan Africa (developing only) in 1996 to that in 1999?
Your answer should be compact. 0.98. What is the ratio of the Pupil-teacher ratio(headcount basis) in Kyrgyz Republic in 1996 to that in 1999?
Your answer should be compact. 0.95. What is the ratio of the Pupil-teacher ratio(headcount basis) of Monaco in 1996 to that in 1999?
Provide a short and direct response. 0.98. What is the ratio of the Pupil-teacher ratio(headcount basis) of Syrian Arab Republic in 1996 to that in 1999?
Give a very brief answer. 0.77. What is the ratio of the Pupil-teacher ratio(headcount basis) of Kyrgyz Republic in 1996 to that in 2001?
Keep it short and to the point. 0.92. What is the ratio of the Pupil-teacher ratio(headcount basis) in Monaco in 1996 to that in 2001?
Make the answer very short. 0.94. What is the ratio of the Pupil-teacher ratio(headcount basis) of Syrian Arab Republic in 1996 to that in 2001?
Make the answer very short. 0.83. What is the ratio of the Pupil-teacher ratio(headcount basis) in Sub-Saharan Africa (developing only) in 1999 to that in 2001?
Make the answer very short. 1.01. What is the ratio of the Pupil-teacher ratio(headcount basis) of Kyrgyz Republic in 1999 to that in 2001?
Your response must be concise. 0.96. What is the ratio of the Pupil-teacher ratio(headcount basis) of Monaco in 1999 to that in 2001?
Make the answer very short. 0.96. What is the ratio of the Pupil-teacher ratio(headcount basis) of Syrian Arab Republic in 1999 to that in 2001?
Your answer should be very brief. 1.07. What is the difference between the highest and the second highest Pupil-teacher ratio(headcount basis) of Sub-Saharan Africa (developing only)?
Make the answer very short. 0.33. What is the difference between the highest and the second highest Pupil-teacher ratio(headcount basis) in Kyrgyz Republic?
Make the answer very short. 0.16. What is the difference between the highest and the second highest Pupil-teacher ratio(headcount basis) of Monaco?
Keep it short and to the point. 0.49. What is the difference between the highest and the second highest Pupil-teacher ratio(headcount basis) of Syrian Arab Republic?
Your response must be concise. 1.24. What is the difference between the highest and the lowest Pupil-teacher ratio(headcount basis) in Sub-Saharan Africa (developing only)?
Provide a short and direct response. 1.82. What is the difference between the highest and the lowest Pupil-teacher ratio(headcount basis) in Kyrgyz Republic?
Your answer should be compact. 1.11. What is the difference between the highest and the lowest Pupil-teacher ratio(headcount basis) of Monaco?
Keep it short and to the point. 1.12. What is the difference between the highest and the lowest Pupil-teacher ratio(headcount basis) in Syrian Arab Republic?
Provide a succinct answer. 4.35. 